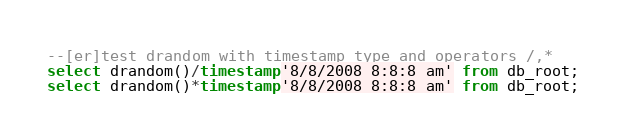Convert code to text. <code><loc_0><loc_0><loc_500><loc_500><_SQL_>--[er]test drandom with timestamp type and operators /,*
select drandom()/timestamp'8/8/2008 8:8:8 am' from db_root;
select drandom()*timestamp'8/8/2008 8:8:8 am' from db_root;
</code> 